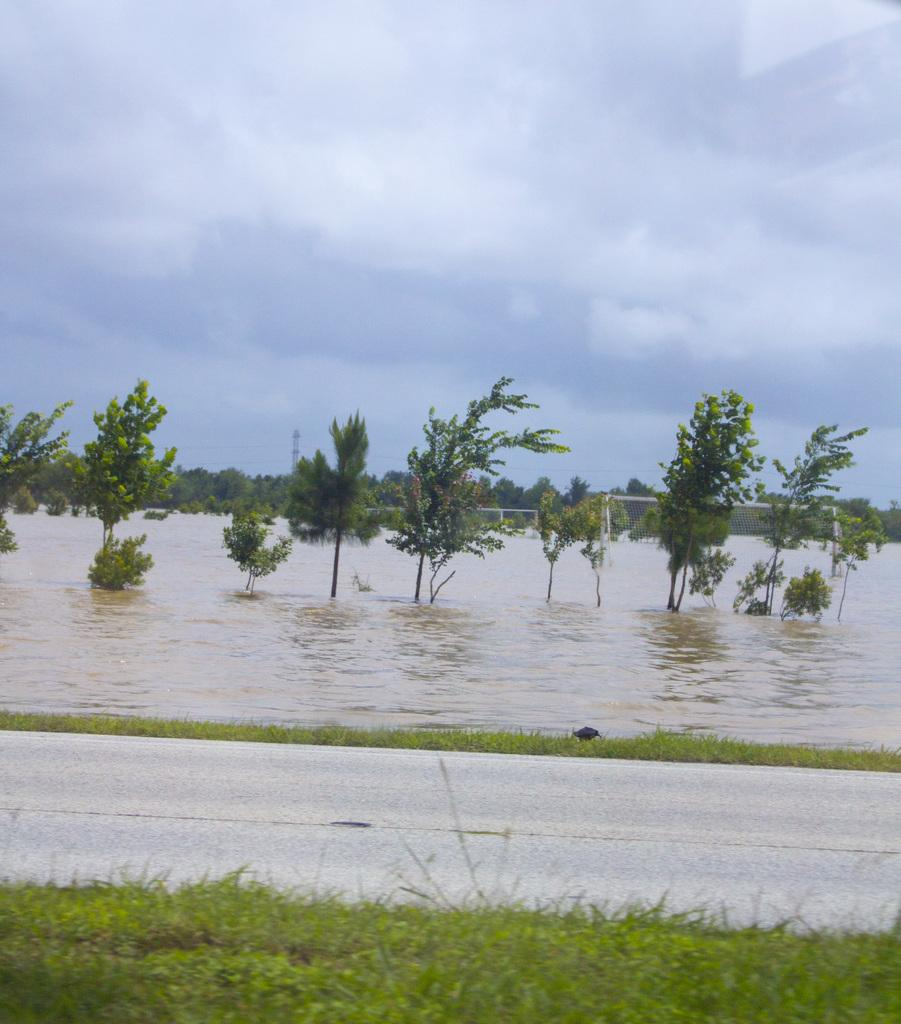What can be seen in the image that is not solid? Water is visible in the image, which is not solid. What type of vegetation is present in the image? There are trees in the image. What tall structure can be seen in the image? There is a tower in the image. What is visible in the background of the image? The sky is visible in the image, and clouds are present in the sky. What type of ground surface is visible in the image? Grass is visible in the image. What type of pencil can be seen in the image? There is no pencil present in the image. Is there a bear visible in the image? No, there is no bear visible in the image. 